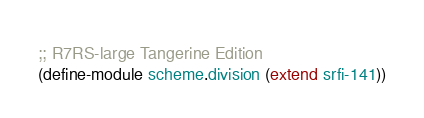<code> <loc_0><loc_0><loc_500><loc_500><_Scheme_>;; R7RS-large Tangerine Edition
(define-module scheme.division (extend srfi-141))

</code> 